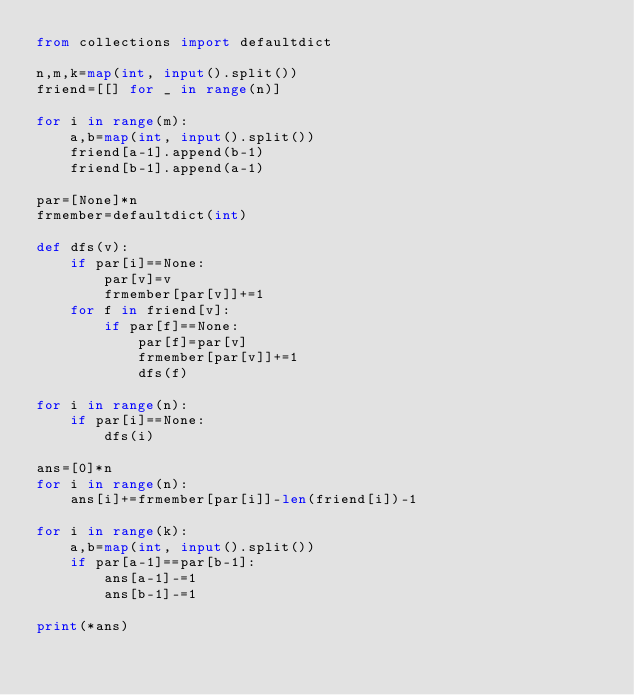<code> <loc_0><loc_0><loc_500><loc_500><_Python_>from collections import defaultdict

n,m,k=map(int, input().split())  
friend=[[] for _ in range(n)]

for i in range(m):
    a,b=map(int, input().split()) 
    friend[a-1].append(b-1)
    friend[b-1].append(a-1)

par=[None]*n
frmember=defaultdict(int)

def dfs(v):
    if par[i]==None:
        par[v]=v
        frmember[par[v]]+=1
    for f in friend[v]:
        if par[f]==None:
            par[f]=par[v]
            frmember[par[v]]+=1
            dfs(f)

for i in range(n):
    if par[i]==None:
        dfs(i)

ans=[0]*n
for i in range(n):
    ans[i]+=frmember[par[i]]-len(friend[i])-1

for i in range(k):
    a,b=map(int, input().split()) 
    if par[a-1]==par[b-1]:
        ans[a-1]-=1
        ans[b-1]-=1

print(*ans)</code> 